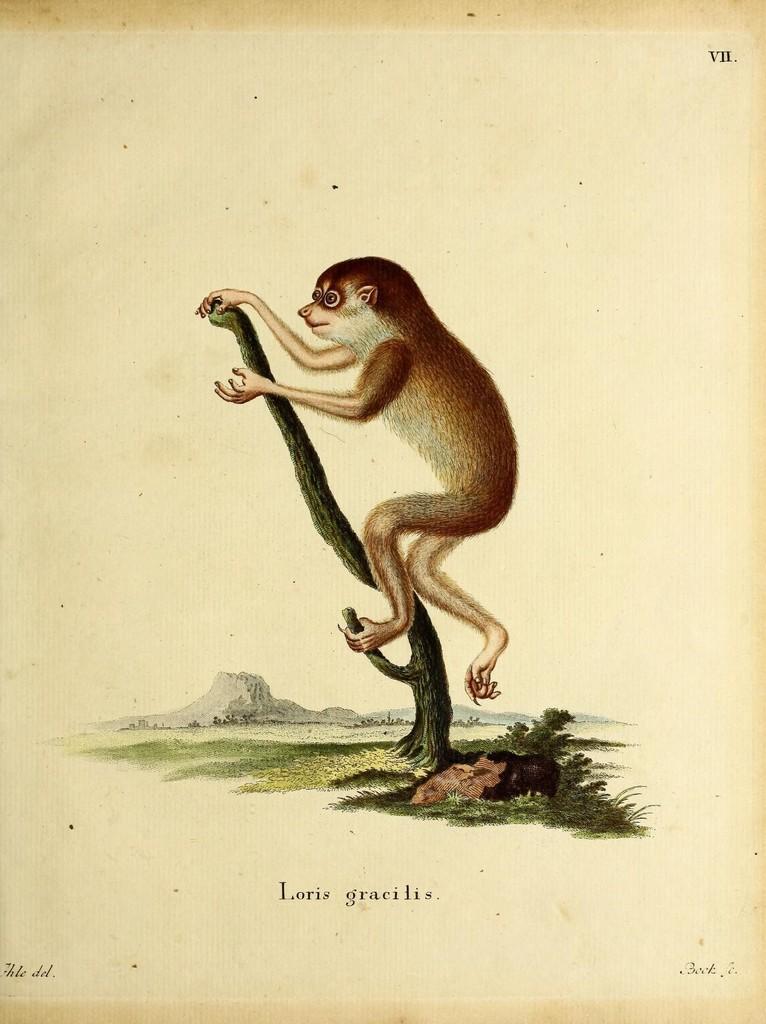Describe this image in one or two sentences. In this image we can see a picture of an animal on the branch of a tree. In the background, we can see grass, mountains and the sky. At the bottom of the image we can see some text. 